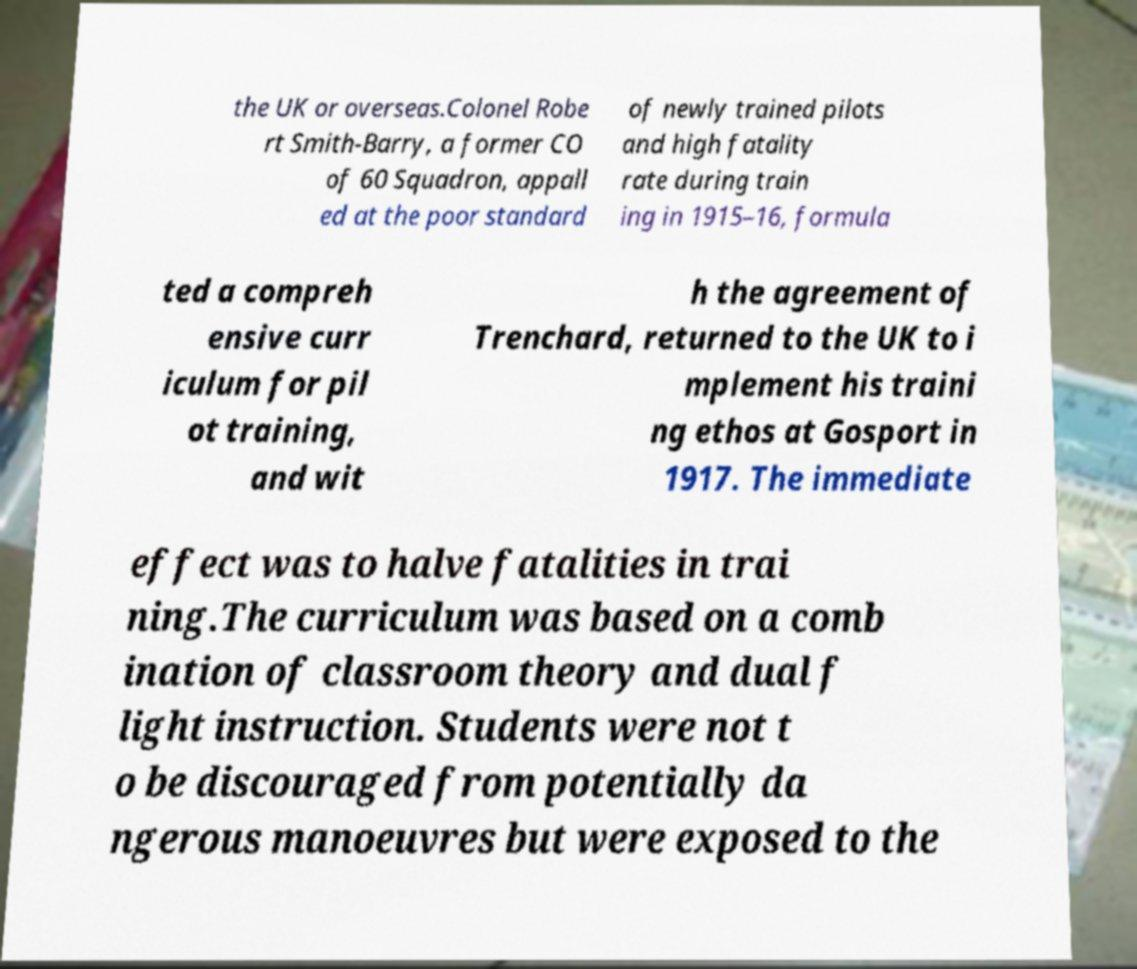Please read and relay the text visible in this image. What does it say? the UK or overseas.Colonel Robe rt Smith-Barry, a former CO of 60 Squadron, appall ed at the poor standard of newly trained pilots and high fatality rate during train ing in 1915–16, formula ted a compreh ensive curr iculum for pil ot training, and wit h the agreement of Trenchard, returned to the UK to i mplement his traini ng ethos at Gosport in 1917. The immediate effect was to halve fatalities in trai ning.The curriculum was based on a comb ination of classroom theory and dual f light instruction. Students were not t o be discouraged from potentially da ngerous manoeuvres but were exposed to the 